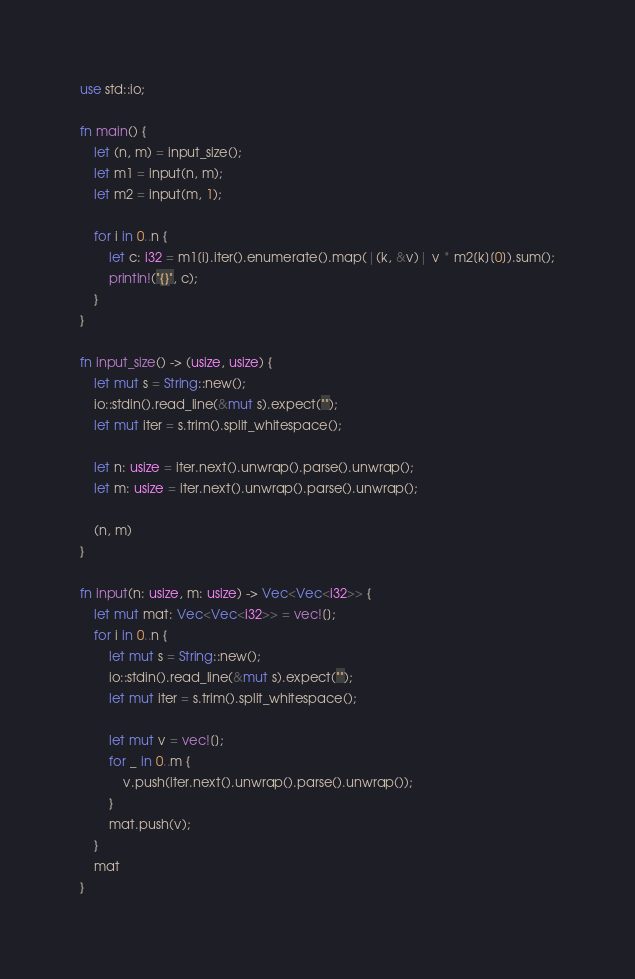Convert code to text. <code><loc_0><loc_0><loc_500><loc_500><_Rust_>use std::io;

fn main() {
    let (n, m) = input_size();
    let m1 = input(n, m);
    let m2 = input(m, 1);

    for i in 0..n {
        let c: i32 = m1[i].iter().enumerate().map(|(k, &v)| v * m2[k][0]).sum();
        println!("{}", c);
    }
}

fn input_size() -> (usize, usize) {
    let mut s = String::new();
    io::stdin().read_line(&mut s).expect("");
    let mut iter = s.trim().split_whitespace();

    let n: usize = iter.next().unwrap().parse().unwrap();
    let m: usize = iter.next().unwrap().parse().unwrap();

    (n, m)
}

fn input(n: usize, m: usize) -> Vec<Vec<i32>> {
    let mut mat: Vec<Vec<i32>> = vec![];
    for i in 0..n {
        let mut s = String::new();
        io::stdin().read_line(&mut s).expect("");
        let mut iter = s.trim().split_whitespace();

        let mut v = vec![];
        for _ in 0..m {
            v.push(iter.next().unwrap().parse().unwrap());
        }
        mat.push(v);
    }
    mat
}
</code> 